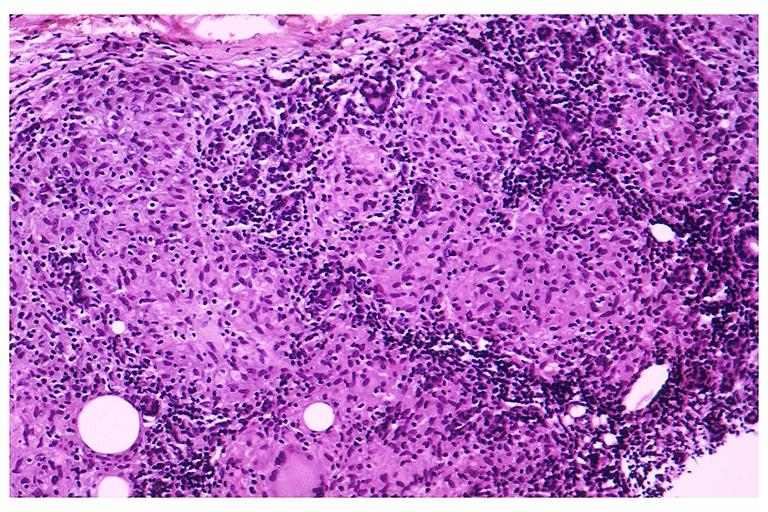s metastatic melanoma present?
Answer the question using a single word or phrase. No 